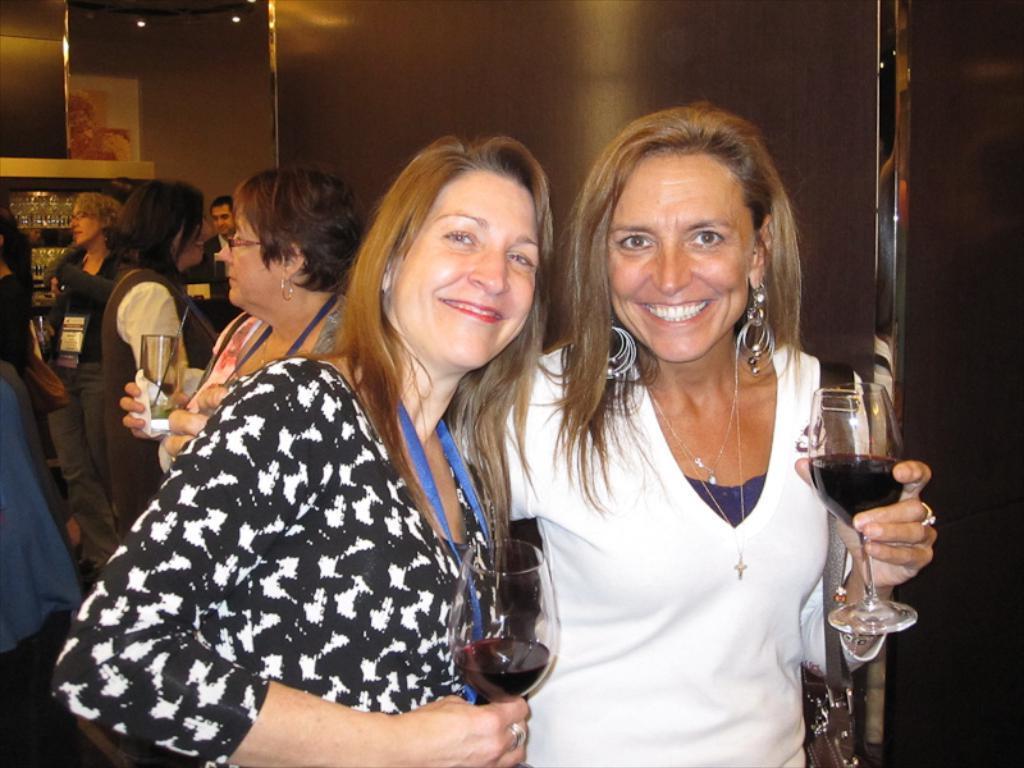How would you summarize this image in a sentence or two? This image is clicked inside a restaurant. In the front, there are two women. Both are holding a wine glass in their hands. To the right, the woman is wearing white dress. To the left, the woman is wearing black dress. In the background, there are many people. 